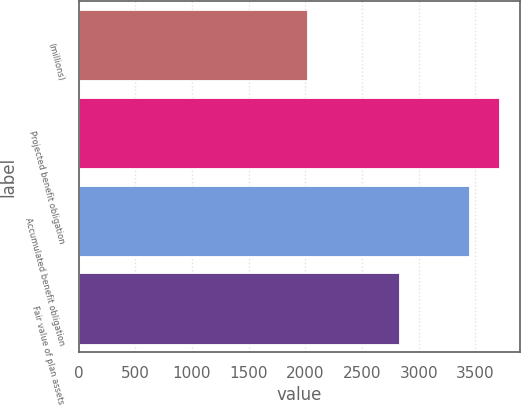Convert chart. <chart><loc_0><loc_0><loc_500><loc_500><bar_chart><fcel>(millions)<fcel>Projected benefit obligation<fcel>Accumulated benefit obligation<fcel>Fair value of plan assets<nl><fcel>2012<fcel>3707<fcel>3442<fcel>2823<nl></chart> 